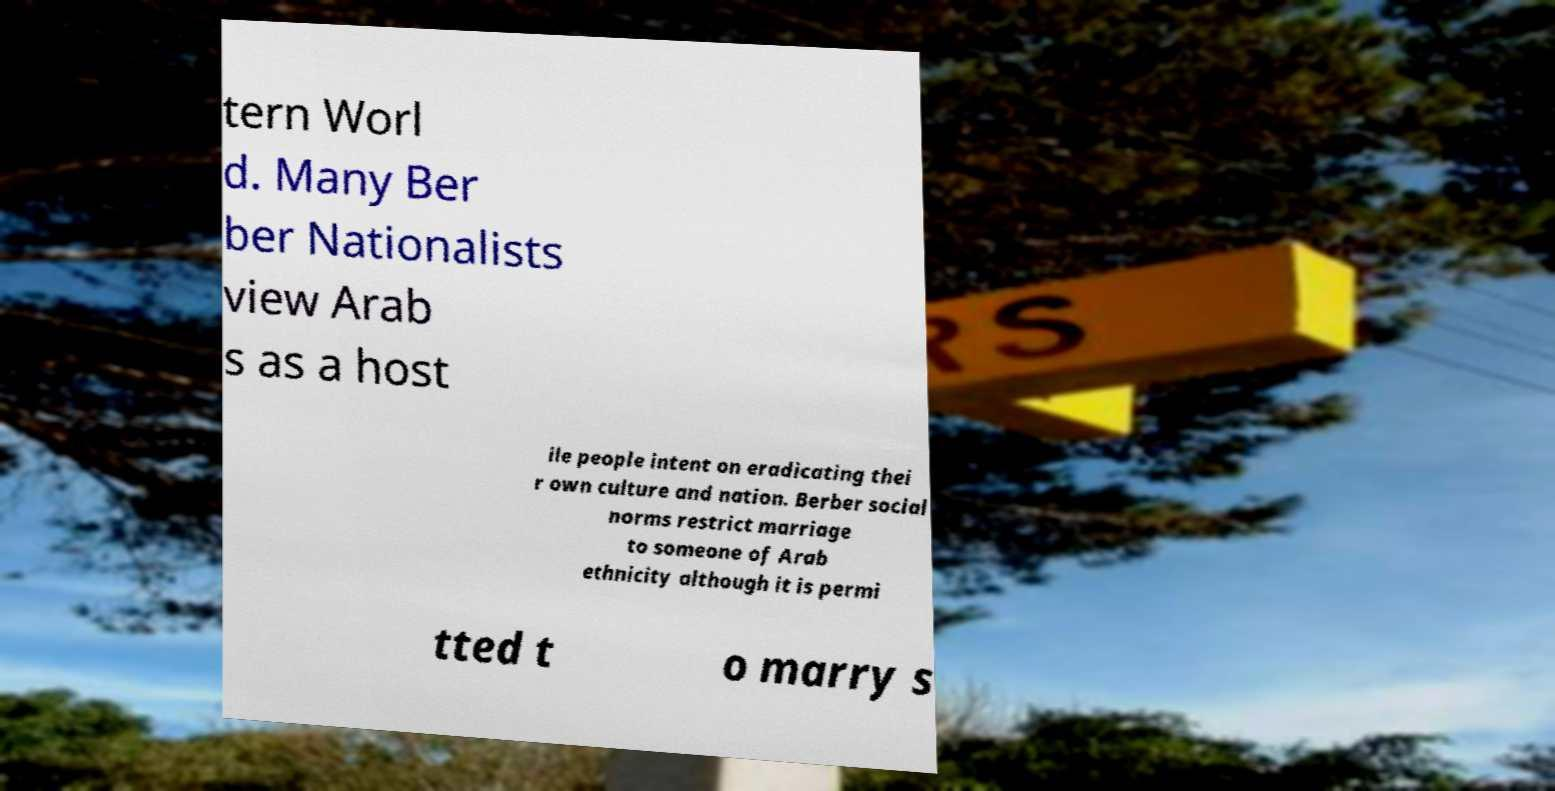Can you accurately transcribe the text from the provided image for me? tern Worl d. Many Ber ber Nationalists view Arab s as a host ile people intent on eradicating thei r own culture and nation. Berber social norms restrict marriage to someone of Arab ethnicity although it is permi tted t o marry s 